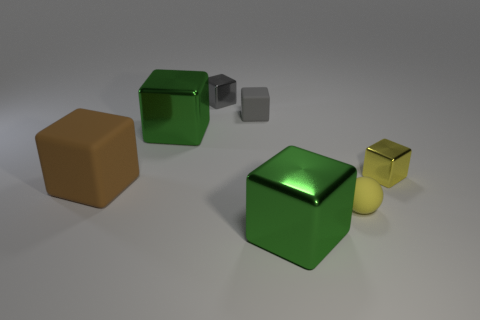Subtract all gray metal cubes. How many cubes are left? 5 Subtract 3 cubes. How many cubes are left? 3 Add 1 green shiny blocks. How many objects exist? 8 Subtract all purple cylinders. How many green blocks are left? 2 Subtract all gray cubes. How many cubes are left? 4 Add 3 big things. How many big things are left? 6 Add 3 large brown matte objects. How many large brown matte objects exist? 4 Subtract 0 purple blocks. How many objects are left? 7 Subtract all spheres. How many objects are left? 6 Subtract all red balls. Subtract all yellow cubes. How many balls are left? 1 